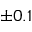Convert formula to latex. <formula><loc_0><loc_0><loc_500><loc_500>\pm 0 . 1</formula> 